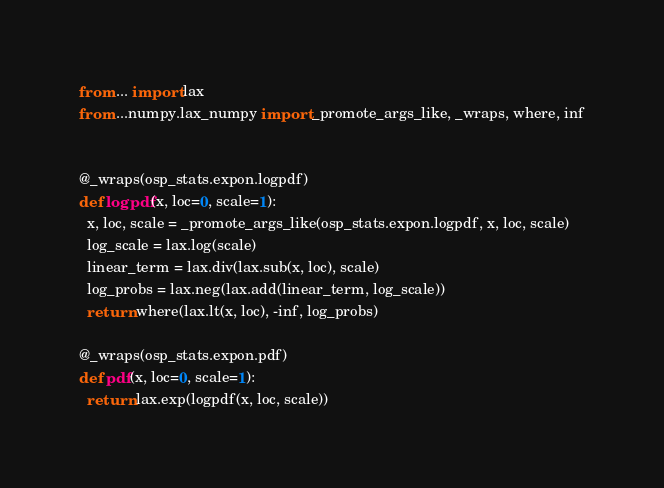Convert code to text. <code><loc_0><loc_0><loc_500><loc_500><_Python_>
from ... import lax
from ...numpy.lax_numpy import _promote_args_like, _wraps, where, inf


@_wraps(osp_stats.expon.logpdf)
def logpdf(x, loc=0, scale=1):
  x, loc, scale = _promote_args_like(osp_stats.expon.logpdf, x, loc, scale)
  log_scale = lax.log(scale)
  linear_term = lax.div(lax.sub(x, loc), scale)
  log_probs = lax.neg(lax.add(linear_term, log_scale))
  return where(lax.lt(x, loc), -inf, log_probs)

@_wraps(osp_stats.expon.pdf)
def pdf(x, loc=0, scale=1):
  return lax.exp(logpdf(x, loc, scale))
</code> 